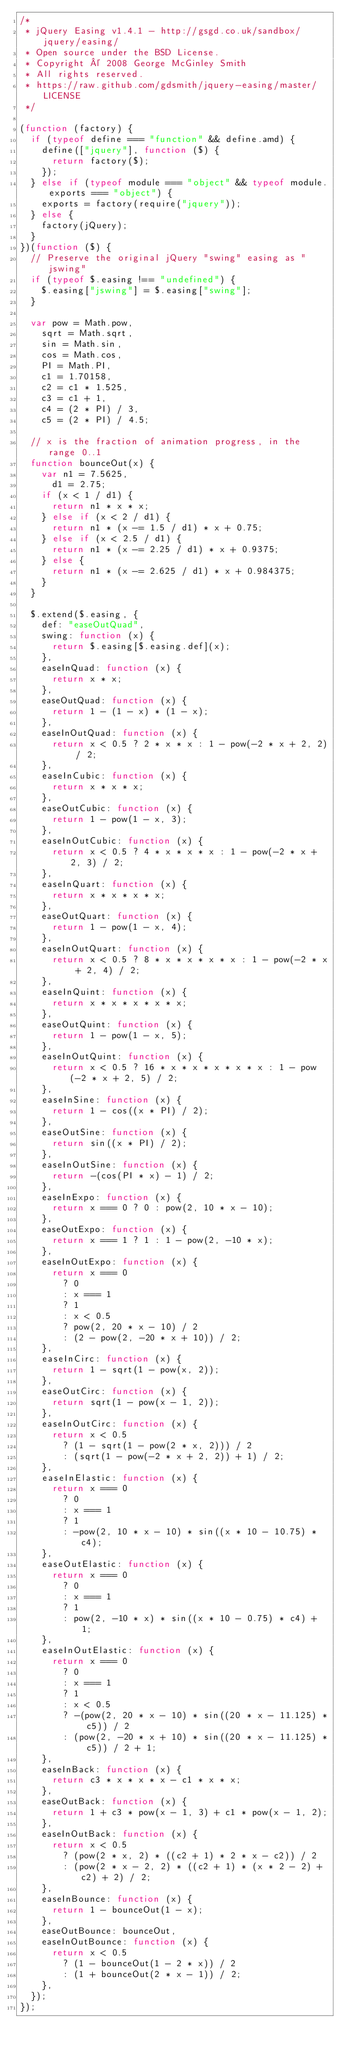<code> <loc_0><loc_0><loc_500><loc_500><_JavaScript_>/*
 * jQuery Easing v1.4.1 - http://gsgd.co.uk/sandbox/jquery/easing/
 * Open source under the BSD License.
 * Copyright © 2008 George McGinley Smith
 * All rights reserved.
 * https://raw.github.com/gdsmith/jquery-easing/master/LICENSE
 */

(function (factory) {
  if (typeof define === "function" && define.amd) {
    define(["jquery"], function ($) {
      return factory($);
    });
  } else if (typeof module === "object" && typeof module.exports === "object") {
    exports = factory(require("jquery"));
  } else {
    factory(jQuery);
  }
})(function ($) {
  // Preserve the original jQuery "swing" easing as "jswing"
  if (typeof $.easing !== "undefined") {
    $.easing["jswing"] = $.easing["swing"];
  }

  var pow = Math.pow,
    sqrt = Math.sqrt,
    sin = Math.sin,
    cos = Math.cos,
    PI = Math.PI,
    c1 = 1.70158,
    c2 = c1 * 1.525,
    c3 = c1 + 1,
    c4 = (2 * PI) / 3,
    c5 = (2 * PI) / 4.5;

  // x is the fraction of animation progress, in the range 0..1
  function bounceOut(x) {
    var n1 = 7.5625,
      d1 = 2.75;
    if (x < 1 / d1) {
      return n1 * x * x;
    } else if (x < 2 / d1) {
      return n1 * (x -= 1.5 / d1) * x + 0.75;
    } else if (x < 2.5 / d1) {
      return n1 * (x -= 2.25 / d1) * x + 0.9375;
    } else {
      return n1 * (x -= 2.625 / d1) * x + 0.984375;
    }
  }

  $.extend($.easing, {
    def: "easeOutQuad",
    swing: function (x) {
      return $.easing[$.easing.def](x);
    },
    easeInQuad: function (x) {
      return x * x;
    },
    easeOutQuad: function (x) {
      return 1 - (1 - x) * (1 - x);
    },
    easeInOutQuad: function (x) {
      return x < 0.5 ? 2 * x * x : 1 - pow(-2 * x + 2, 2) / 2;
    },
    easeInCubic: function (x) {
      return x * x * x;
    },
    easeOutCubic: function (x) {
      return 1 - pow(1 - x, 3);
    },
    easeInOutCubic: function (x) {
      return x < 0.5 ? 4 * x * x * x : 1 - pow(-2 * x + 2, 3) / 2;
    },
    easeInQuart: function (x) {
      return x * x * x * x;
    },
    easeOutQuart: function (x) {
      return 1 - pow(1 - x, 4);
    },
    easeInOutQuart: function (x) {
      return x < 0.5 ? 8 * x * x * x * x : 1 - pow(-2 * x + 2, 4) / 2;
    },
    easeInQuint: function (x) {
      return x * x * x * x * x;
    },
    easeOutQuint: function (x) {
      return 1 - pow(1 - x, 5);
    },
    easeInOutQuint: function (x) {
      return x < 0.5 ? 16 * x * x * x * x * x : 1 - pow(-2 * x + 2, 5) / 2;
    },
    easeInSine: function (x) {
      return 1 - cos((x * PI) / 2);
    },
    easeOutSine: function (x) {
      return sin((x * PI) / 2);
    },
    easeInOutSine: function (x) {
      return -(cos(PI * x) - 1) / 2;
    },
    easeInExpo: function (x) {
      return x === 0 ? 0 : pow(2, 10 * x - 10);
    },
    easeOutExpo: function (x) {
      return x === 1 ? 1 : 1 - pow(2, -10 * x);
    },
    easeInOutExpo: function (x) {
      return x === 0
        ? 0
        : x === 1
        ? 1
        : x < 0.5
        ? pow(2, 20 * x - 10) / 2
        : (2 - pow(2, -20 * x + 10)) / 2;
    },
    easeInCirc: function (x) {
      return 1 - sqrt(1 - pow(x, 2));
    },
    easeOutCirc: function (x) {
      return sqrt(1 - pow(x - 1, 2));
    },
    easeInOutCirc: function (x) {
      return x < 0.5
        ? (1 - sqrt(1 - pow(2 * x, 2))) / 2
        : (sqrt(1 - pow(-2 * x + 2, 2)) + 1) / 2;
    },
    easeInElastic: function (x) {
      return x === 0
        ? 0
        : x === 1
        ? 1
        : -pow(2, 10 * x - 10) * sin((x * 10 - 10.75) * c4);
    },
    easeOutElastic: function (x) {
      return x === 0
        ? 0
        : x === 1
        ? 1
        : pow(2, -10 * x) * sin((x * 10 - 0.75) * c4) + 1;
    },
    easeInOutElastic: function (x) {
      return x === 0
        ? 0
        : x === 1
        ? 1
        : x < 0.5
        ? -(pow(2, 20 * x - 10) * sin((20 * x - 11.125) * c5)) / 2
        : (pow(2, -20 * x + 10) * sin((20 * x - 11.125) * c5)) / 2 + 1;
    },
    easeInBack: function (x) {
      return c3 * x * x * x - c1 * x * x;
    },
    easeOutBack: function (x) {
      return 1 + c3 * pow(x - 1, 3) + c1 * pow(x - 1, 2);
    },
    easeInOutBack: function (x) {
      return x < 0.5
        ? (pow(2 * x, 2) * ((c2 + 1) * 2 * x - c2)) / 2
        : (pow(2 * x - 2, 2) * ((c2 + 1) * (x * 2 - 2) + c2) + 2) / 2;
    },
    easeInBounce: function (x) {
      return 1 - bounceOut(1 - x);
    },
    easeOutBounce: bounceOut,
    easeInOutBounce: function (x) {
      return x < 0.5
        ? (1 - bounceOut(1 - 2 * x)) / 2
        : (1 + bounceOut(2 * x - 1)) / 2;
    },
  });
});
</code> 